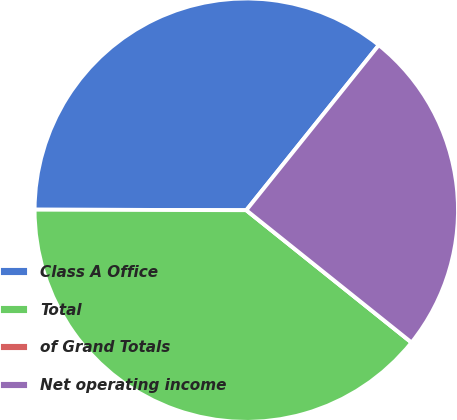Convert chart to OTSL. <chart><loc_0><loc_0><loc_500><loc_500><pie_chart><fcel>Class A Office<fcel>Total<fcel>of Grand Totals<fcel>Net operating income<nl><fcel>35.72%<fcel>39.29%<fcel>0.0%<fcel>24.98%<nl></chart> 